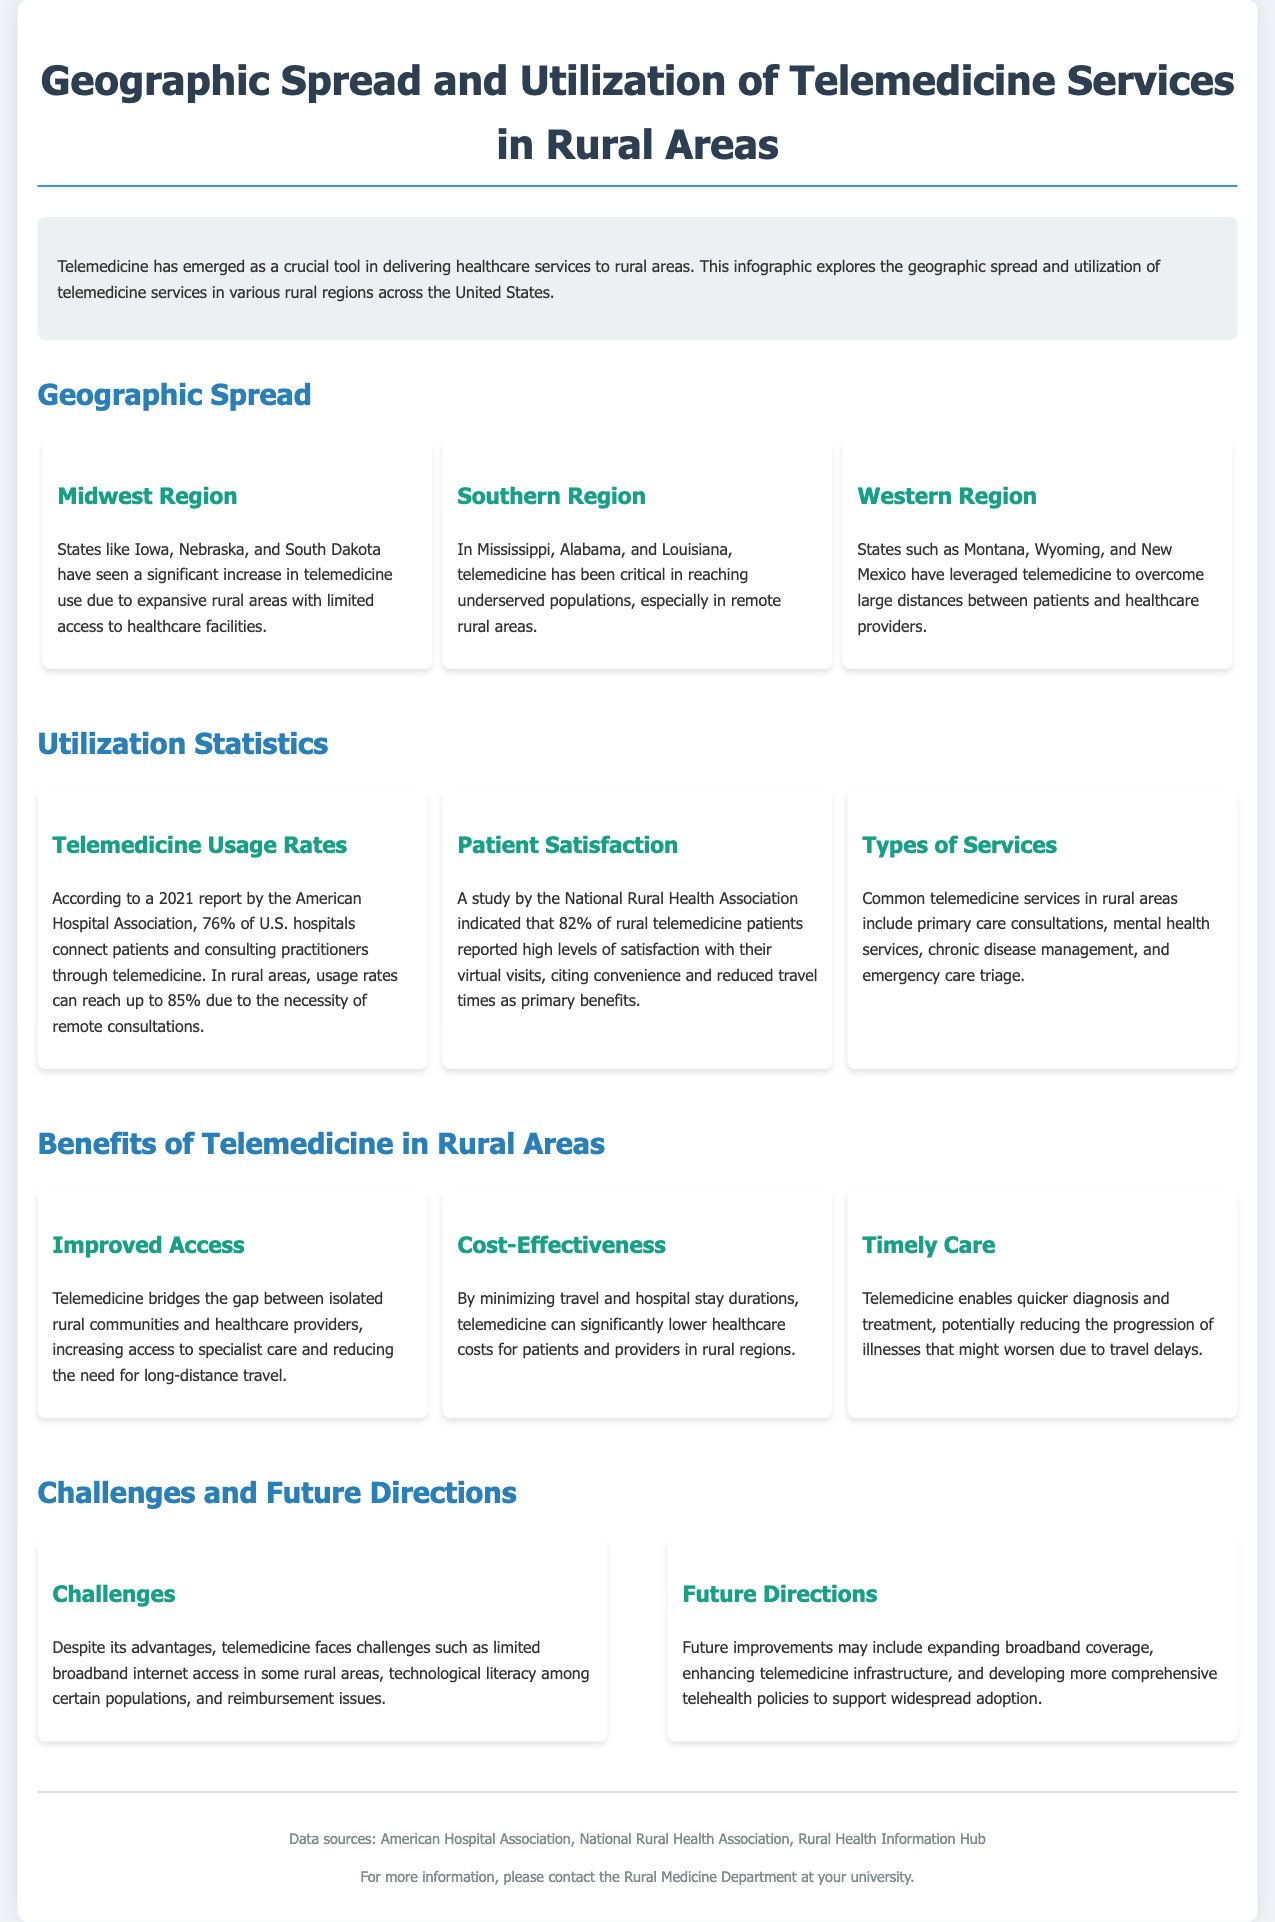What regions are highlighted in the geographic spread section? The regions highlighted are the Midwest, Southern, and Western regions.
Answer: Midwest, Southern, Western What percentage of U.S. hospitals connect patients through telemedicine? According to the document, 76% of U.S. hospitals use telemedicine to connect patients.
Answer: 76% What is the reported patient satisfaction percentage for rural telemedicine patients? The study indicated that 82% of rural telemedicine patients reported high satisfaction levels.
Answer: 82% Which types of services are commonly offered through telemedicine in rural areas? Common services include primary care consultations, mental health services, chronic disease management, and emergency care triage.
Answer: Primary care consultations, mental health services, chronic disease management, and emergency care triage What is a significant challenge faced by telemedicine in rural areas? A significant challenge is limited broadband internet access in some rural areas.
Answer: Limited broadband internet access What is one future direction mentioned for improving telemedicine services? Future improvements may include expanding broadband coverage.
Answer: Expanding broadband coverage Which state is mentioned as having critical telemedicine reach for underserved populations? Mississippi is mentioned as a state that has critical telemedicine reach.
Answer: Mississippi What is one benefit of telemedicine in rural areas? One benefit is improved access to specialist care.
Answer: Improved access to specialist care 